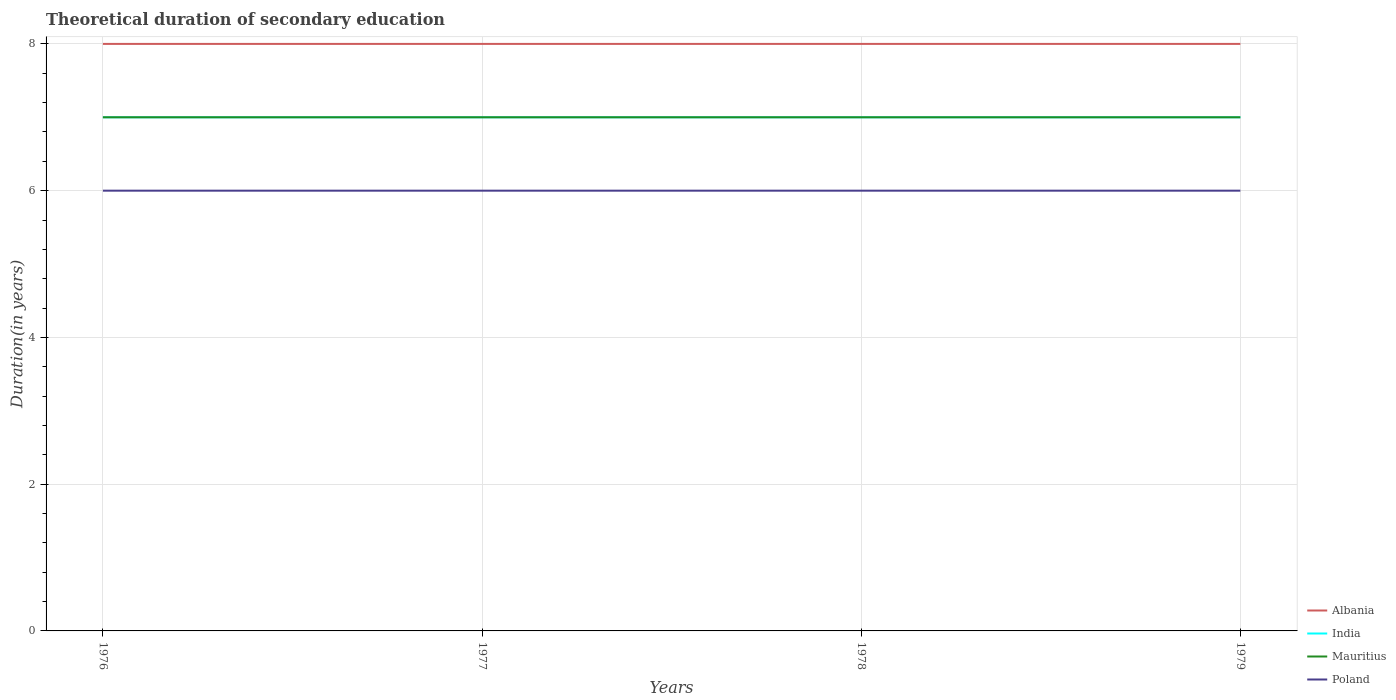Does the line corresponding to Albania intersect with the line corresponding to India?
Offer a very short reply. No. Is the number of lines equal to the number of legend labels?
Keep it short and to the point. Yes. In which year was the total theoretical duration of secondary education in Poland maximum?
Your response must be concise. 1976. What is the total total theoretical duration of secondary education in Mauritius in the graph?
Offer a very short reply. 0. What is the difference between the highest and the lowest total theoretical duration of secondary education in Mauritius?
Your answer should be very brief. 0. How many lines are there?
Provide a succinct answer. 4. How many years are there in the graph?
Your answer should be compact. 4. What is the difference between two consecutive major ticks on the Y-axis?
Provide a succinct answer. 2. Are the values on the major ticks of Y-axis written in scientific E-notation?
Ensure brevity in your answer.  No. How many legend labels are there?
Offer a terse response. 4. How are the legend labels stacked?
Provide a succinct answer. Vertical. What is the title of the graph?
Provide a succinct answer. Theoretical duration of secondary education. Does "Comoros" appear as one of the legend labels in the graph?
Your answer should be very brief. No. What is the label or title of the Y-axis?
Provide a succinct answer. Duration(in years). What is the Duration(in years) in India in 1976?
Give a very brief answer. 7. What is the Duration(in years) of Mauritius in 1976?
Make the answer very short. 7. What is the Duration(in years) in Poland in 1976?
Provide a succinct answer. 6. What is the Duration(in years) of Albania in 1977?
Ensure brevity in your answer.  8. What is the Duration(in years) of India in 1977?
Offer a terse response. 7. What is the Duration(in years) of Poland in 1977?
Make the answer very short. 6. What is the Duration(in years) in Albania in 1978?
Provide a succinct answer. 8. What is the Duration(in years) of Poland in 1978?
Ensure brevity in your answer.  6. What is the Duration(in years) of India in 1979?
Your answer should be compact. 7. Across all years, what is the maximum Duration(in years) in India?
Your response must be concise. 7. Across all years, what is the maximum Duration(in years) in Mauritius?
Your answer should be compact. 7. Across all years, what is the minimum Duration(in years) in Poland?
Your answer should be compact. 6. What is the total Duration(in years) in Albania in the graph?
Give a very brief answer. 32. What is the total Duration(in years) in Poland in the graph?
Your response must be concise. 24. What is the difference between the Duration(in years) of Mauritius in 1976 and that in 1977?
Your response must be concise. 0. What is the difference between the Duration(in years) of India in 1976 and that in 1978?
Provide a succinct answer. 0. What is the difference between the Duration(in years) of Mauritius in 1976 and that in 1978?
Your answer should be very brief. 0. What is the difference between the Duration(in years) of Poland in 1976 and that in 1978?
Keep it short and to the point. 0. What is the difference between the Duration(in years) in Albania in 1977 and that in 1978?
Make the answer very short. 0. What is the difference between the Duration(in years) in Mauritius in 1977 and that in 1978?
Provide a short and direct response. 0. What is the difference between the Duration(in years) in Poland in 1977 and that in 1979?
Your response must be concise. 0. What is the difference between the Duration(in years) of Albania in 1978 and that in 1979?
Keep it short and to the point. 0. What is the difference between the Duration(in years) in India in 1978 and that in 1979?
Your response must be concise. 0. What is the difference between the Duration(in years) of Mauritius in 1978 and that in 1979?
Your response must be concise. 0. What is the difference between the Duration(in years) in Albania in 1976 and the Duration(in years) in Mauritius in 1977?
Give a very brief answer. 1. What is the difference between the Duration(in years) in Albania in 1976 and the Duration(in years) in Poland in 1977?
Offer a very short reply. 2. What is the difference between the Duration(in years) in Mauritius in 1976 and the Duration(in years) in Poland in 1977?
Provide a short and direct response. 1. What is the difference between the Duration(in years) in Albania in 1976 and the Duration(in years) in India in 1978?
Offer a very short reply. 1. What is the difference between the Duration(in years) of Albania in 1976 and the Duration(in years) of Mauritius in 1978?
Ensure brevity in your answer.  1. What is the difference between the Duration(in years) of Albania in 1976 and the Duration(in years) of Poland in 1978?
Your answer should be compact. 2. What is the difference between the Duration(in years) in Albania in 1976 and the Duration(in years) in Mauritius in 1979?
Ensure brevity in your answer.  1. What is the difference between the Duration(in years) in India in 1976 and the Duration(in years) in Mauritius in 1979?
Offer a terse response. 0. What is the difference between the Duration(in years) of Albania in 1977 and the Duration(in years) of India in 1978?
Your answer should be compact. 1. What is the difference between the Duration(in years) of Albania in 1977 and the Duration(in years) of Mauritius in 1978?
Keep it short and to the point. 1. What is the difference between the Duration(in years) of Albania in 1977 and the Duration(in years) of Poland in 1978?
Your response must be concise. 2. What is the difference between the Duration(in years) of Albania in 1977 and the Duration(in years) of Poland in 1979?
Your answer should be compact. 2. What is the difference between the Duration(in years) in India in 1977 and the Duration(in years) in Poland in 1979?
Provide a short and direct response. 1. What is the difference between the Duration(in years) of India in 1978 and the Duration(in years) of Mauritius in 1979?
Offer a very short reply. 0. What is the average Duration(in years) in Mauritius per year?
Keep it short and to the point. 7. In the year 1976, what is the difference between the Duration(in years) in Albania and Duration(in years) in Poland?
Your response must be concise. 2. In the year 1976, what is the difference between the Duration(in years) of India and Duration(in years) of Poland?
Ensure brevity in your answer.  1. In the year 1976, what is the difference between the Duration(in years) in Mauritius and Duration(in years) in Poland?
Give a very brief answer. 1. In the year 1977, what is the difference between the Duration(in years) of Albania and Duration(in years) of Mauritius?
Provide a short and direct response. 1. In the year 1977, what is the difference between the Duration(in years) of Mauritius and Duration(in years) of Poland?
Your response must be concise. 1. In the year 1978, what is the difference between the Duration(in years) of Albania and Duration(in years) of India?
Provide a short and direct response. 1. In the year 1978, what is the difference between the Duration(in years) of Albania and Duration(in years) of Poland?
Offer a very short reply. 2. In the year 1978, what is the difference between the Duration(in years) of India and Duration(in years) of Poland?
Make the answer very short. 1. In the year 1979, what is the difference between the Duration(in years) of Albania and Duration(in years) of India?
Provide a short and direct response. 1. In the year 1979, what is the difference between the Duration(in years) of Mauritius and Duration(in years) of Poland?
Your answer should be compact. 1. What is the ratio of the Duration(in years) of Albania in 1976 to that in 1978?
Your response must be concise. 1. What is the ratio of the Duration(in years) in Poland in 1976 to that in 1978?
Make the answer very short. 1. What is the ratio of the Duration(in years) of Albania in 1976 to that in 1979?
Offer a very short reply. 1. What is the ratio of the Duration(in years) in Mauritius in 1976 to that in 1979?
Offer a very short reply. 1. What is the ratio of the Duration(in years) of Mauritius in 1977 to that in 1978?
Provide a short and direct response. 1. What is the ratio of the Duration(in years) in Poland in 1977 to that in 1978?
Your answer should be very brief. 1. What is the ratio of the Duration(in years) in Mauritius in 1977 to that in 1979?
Provide a succinct answer. 1. What is the ratio of the Duration(in years) in Albania in 1978 to that in 1979?
Provide a short and direct response. 1. What is the ratio of the Duration(in years) in Mauritius in 1978 to that in 1979?
Your answer should be compact. 1. What is the difference between the highest and the second highest Duration(in years) of India?
Make the answer very short. 0. What is the difference between the highest and the second highest Duration(in years) in Mauritius?
Provide a short and direct response. 0. What is the difference between the highest and the lowest Duration(in years) of Albania?
Provide a short and direct response. 0. What is the difference between the highest and the lowest Duration(in years) of Poland?
Make the answer very short. 0. 